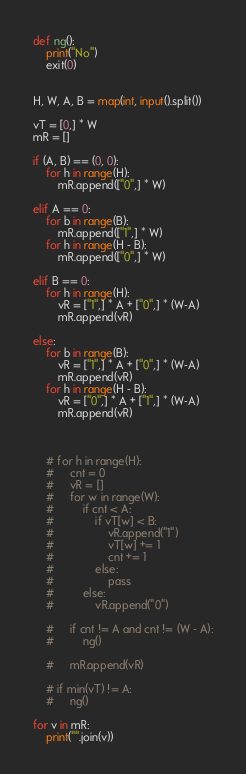<code> <loc_0><loc_0><loc_500><loc_500><_Python_>def ng():
    print("No")
    exit(0)


H, W, A, B = map(int, input().split())

vT = [0,] * W
mR = []

if (A, B) == (0, 0):
    for h in range(H):
        mR.append(["0",] * W)

elif A == 0:
    for b in range(B):
        mR.append(["1",] * W)
    for h in range(H - B):
        mR.append(["0",] * W)

elif B == 0:
    for h in range(H):
        vR = ["1",] * A + ["0",] * (W-A)
        mR.append(vR)

else:
    for b in range(B):
        vR = ["1",] * A + ["0",] * (W-A)
        mR.append(vR)
    for h in range(H - B):
        vR = ["0",] * A + ["1",] * (W-A)
        mR.append(vR)
    
    
    
    # for h in range(H):
    #     cnt = 0
    #     vR = []
    #     for w in range(W):
    #         if cnt < A:
    #             if vT[w] < B:
    #                 vR.append("1")
    #                 vT[w] += 1
    #                 cnt += 1
    #             else:
    #                 pass
    #         else:
    #             vR.append("0")

    #     if cnt != A and cnt != (W - A):
    #         ng()

    #     mR.append(vR)

    # if min(vT) != A:
    #     ng()

for v in mR:
    print("".join(v))
</code> 